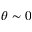Convert formula to latex. <formula><loc_0><loc_0><loc_500><loc_500>\theta \sim 0</formula> 